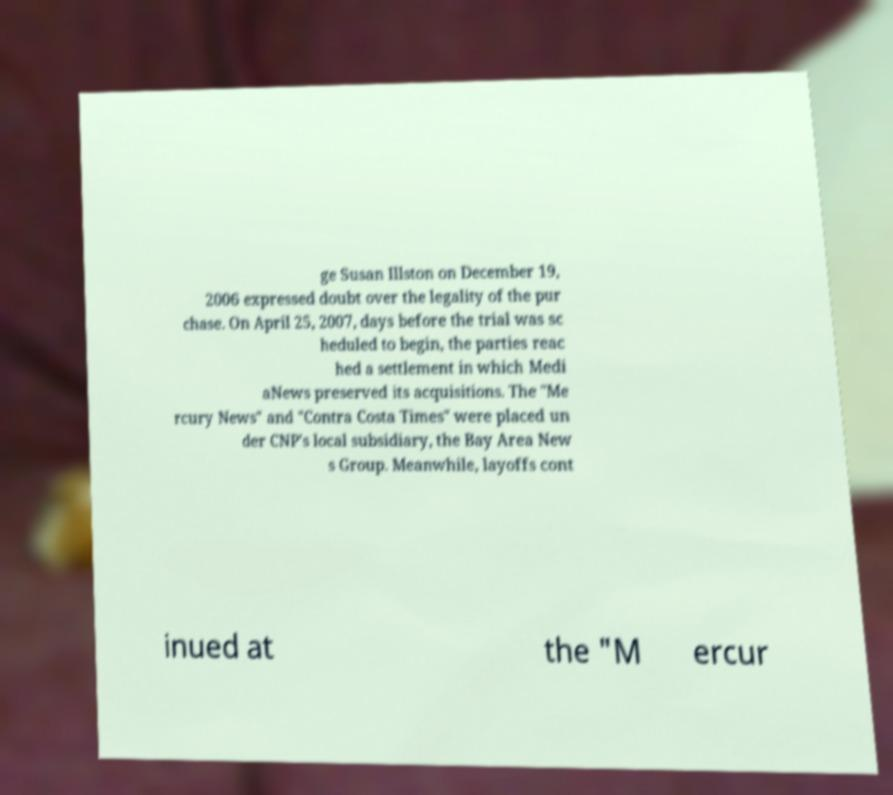Could you assist in decoding the text presented in this image and type it out clearly? ge Susan Illston on December 19, 2006 expressed doubt over the legality of the pur chase. On April 25, 2007, days before the trial was sc heduled to begin, the parties reac hed a settlement in which Medi aNews preserved its acquisitions. The "Me rcury News" and "Contra Costa Times" were placed un der CNP's local subsidiary, the Bay Area New s Group. Meanwhile, layoffs cont inued at the "M ercur 